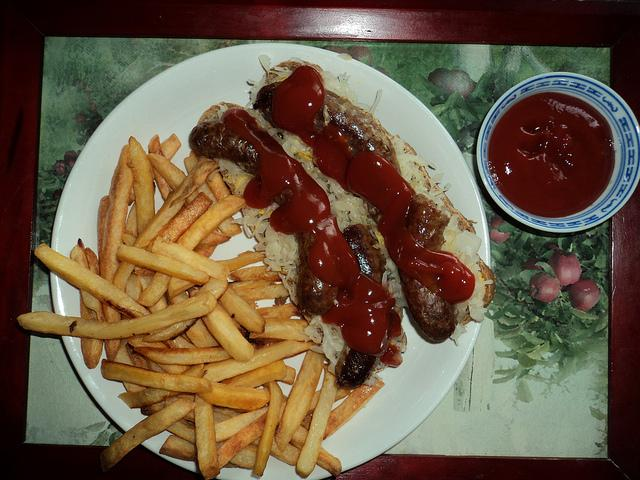What is the red sauce that is covering the hot dog sausages? Please explain your reasoning. ketchup. This is the red item most often put on hot dogs 